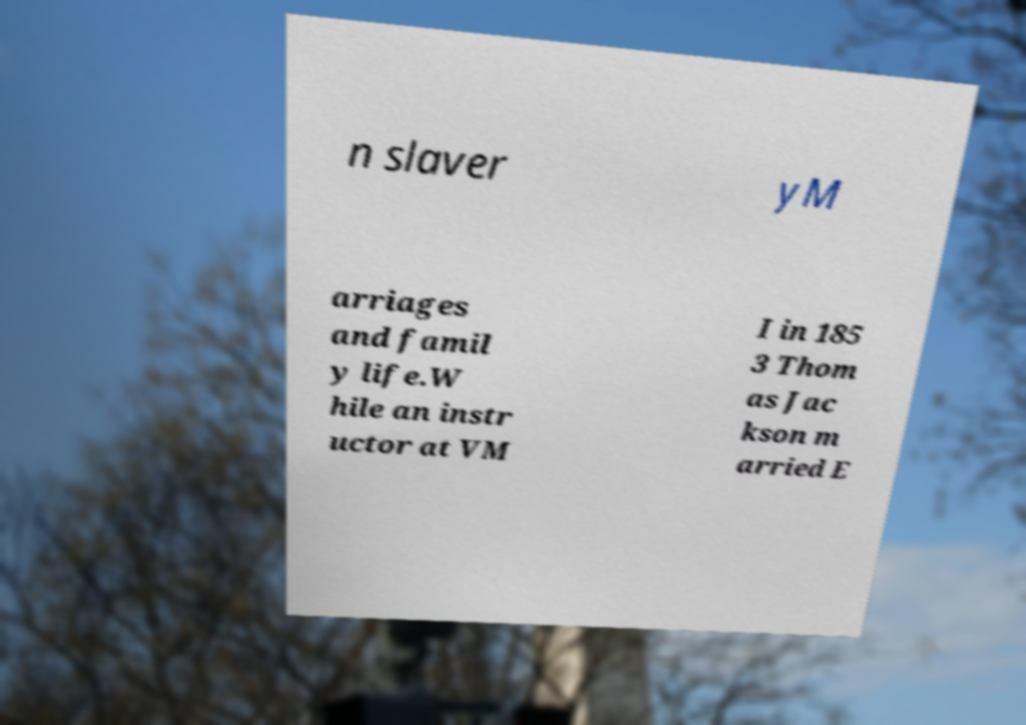Could you extract and type out the text from this image? n slaver yM arriages and famil y life.W hile an instr uctor at VM I in 185 3 Thom as Jac kson m arried E 